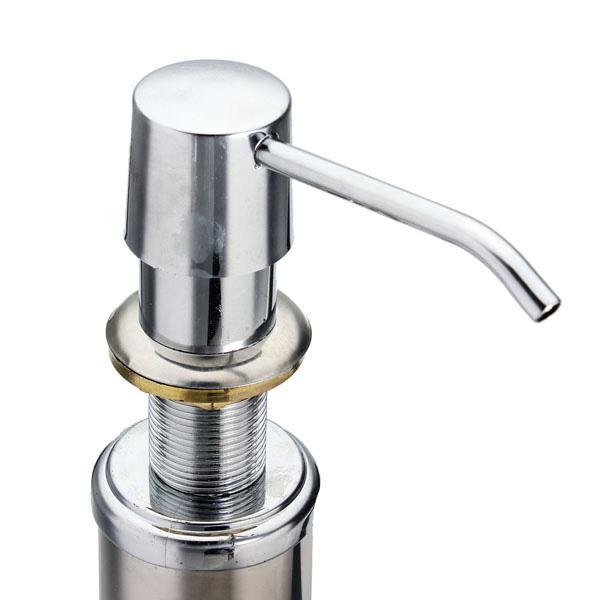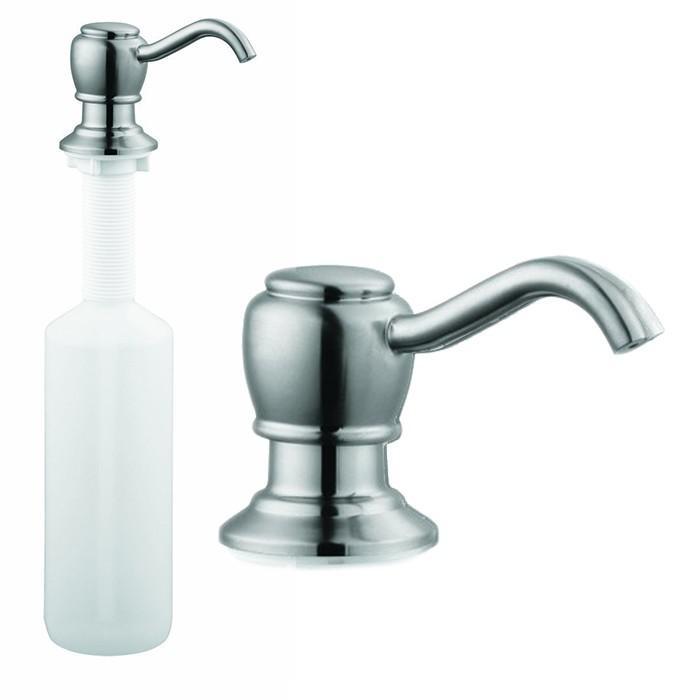The first image is the image on the left, the second image is the image on the right. For the images displayed, is the sentence "There is a circle-shaped inset image in one or more images." factually correct? Answer yes or no. No. 